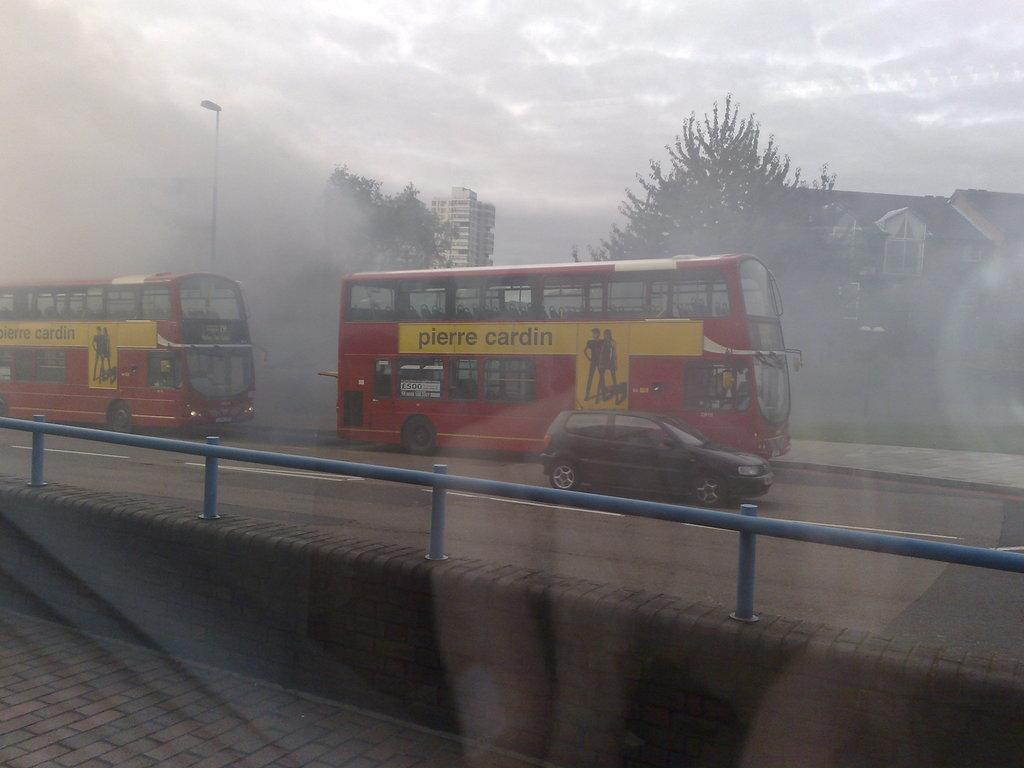<image>
Render a clear and concise summary of the photo. two double decker buses with Pierre Cardin written on the side 